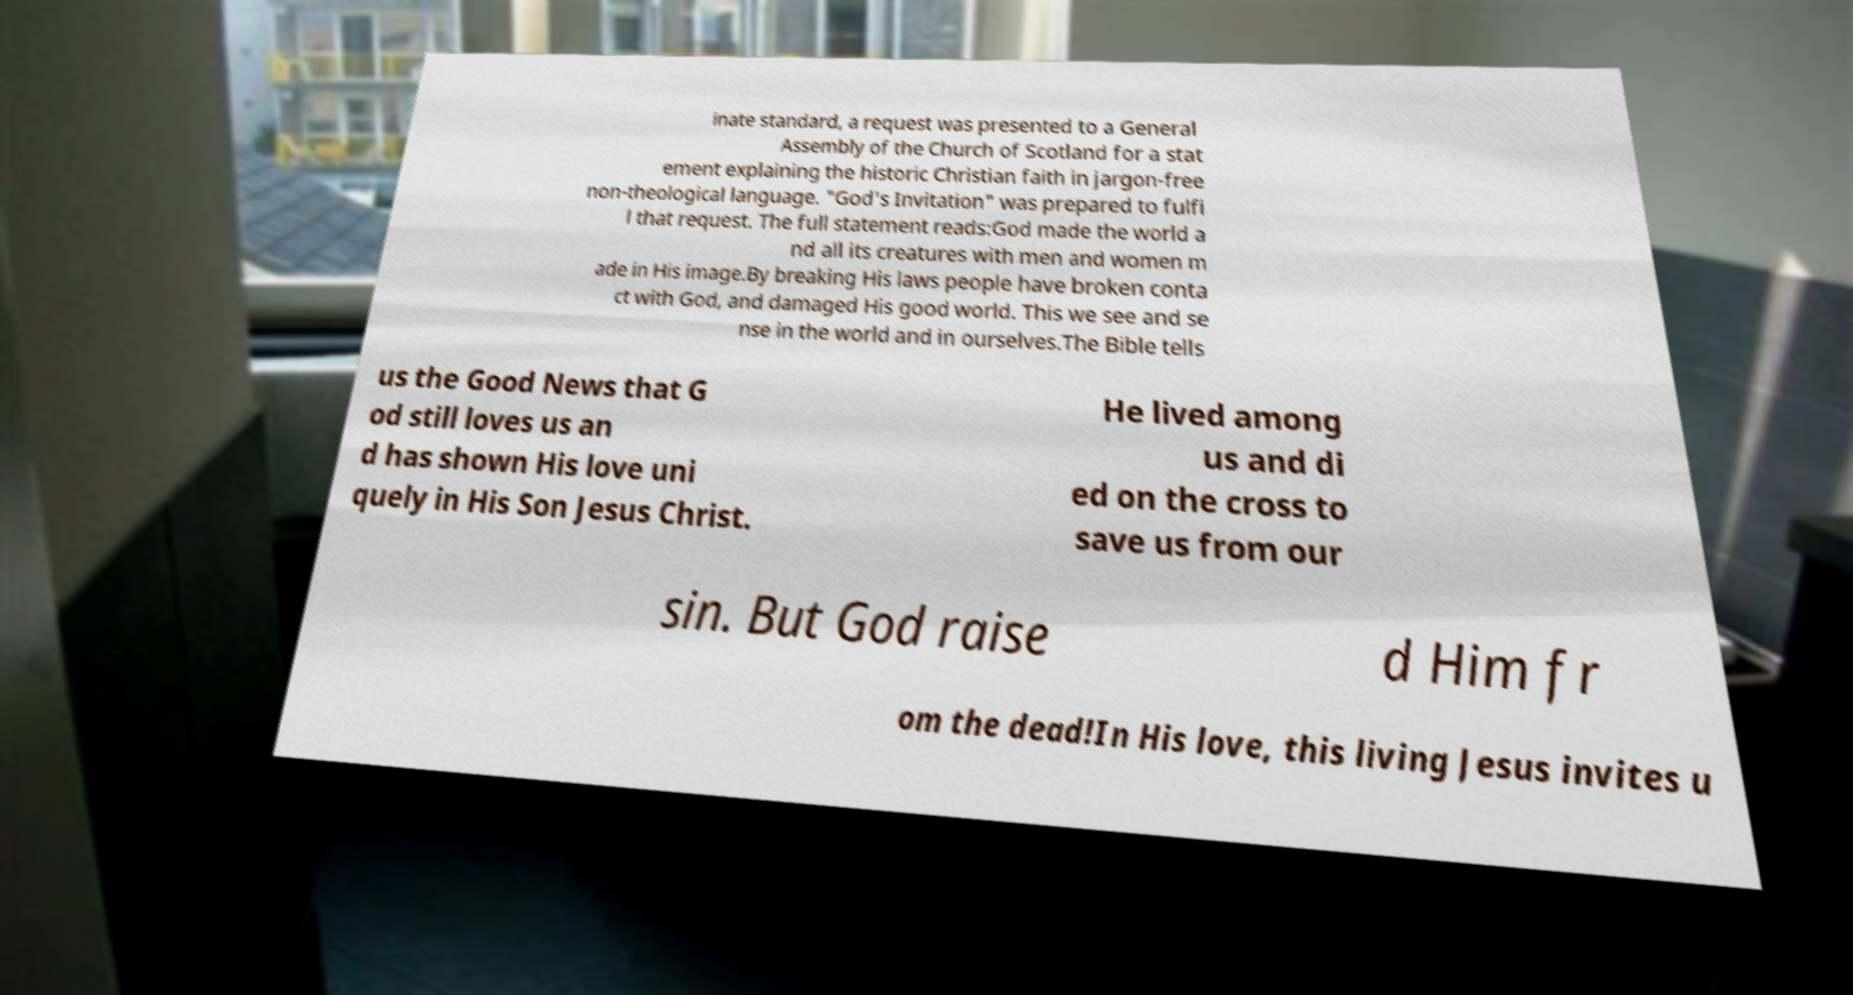Please identify and transcribe the text found in this image. inate standard, a request was presented to a General Assembly of the Church of Scotland for a stat ement explaining the historic Christian faith in jargon-free non-theological language. "God's Invitation" was prepared to fulfi l that request. The full statement reads:God made the world a nd all its creatures with men and women m ade in His image.By breaking His laws people have broken conta ct with God, and damaged His good world. This we see and se nse in the world and in ourselves.The Bible tells us the Good News that G od still loves us an d has shown His love uni quely in His Son Jesus Christ. He lived among us and di ed on the cross to save us from our sin. But God raise d Him fr om the dead!In His love, this living Jesus invites u 